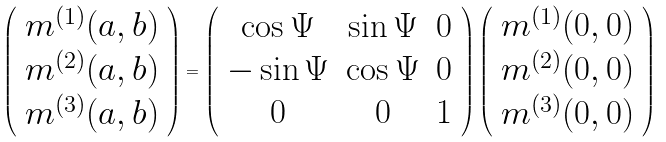Convert formula to latex. <formula><loc_0><loc_0><loc_500><loc_500>\left ( \begin{array} { c } { m } ^ { ( 1 ) } ( { a } , { b } ) \\ { m } ^ { ( 2 ) } ( { a } , { b } ) \\ { m } ^ { ( 3 ) } ( { a } , { b } ) \end{array} \right ) = \left ( \begin{array} { c c c } \cos \Psi & \sin \Psi & 0 \\ - \sin \Psi & \cos \Psi & 0 \\ 0 & 0 & 1 \end{array} \right ) \left ( \begin{array} { c } { m } ^ { ( 1 ) } ( 0 , 0 ) \\ { m } ^ { ( 2 ) } ( 0 , 0 ) \\ { m } ^ { ( 3 ) } ( 0 , 0 ) \end{array} \right )</formula> 